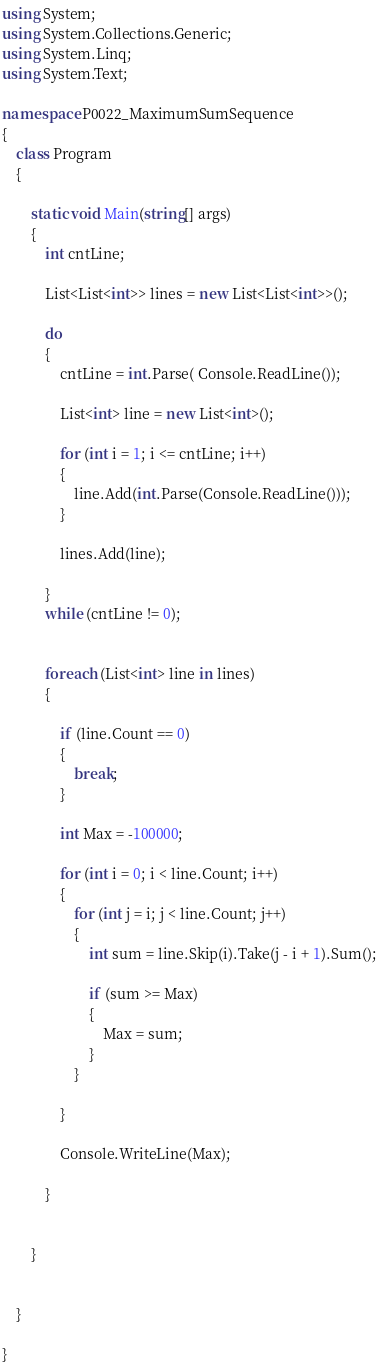Convert code to text. <code><loc_0><loc_0><loc_500><loc_500><_C#_>using System;
using System.Collections.Generic;
using System.Linq;
using System.Text;

namespace P0022_MaximumSumSequence
{
    class Program
    {

        static void Main(string[] args)
        {
            int cntLine;

            List<List<int>> lines = new List<List<int>>();

            do
            {
                cntLine = int.Parse( Console.ReadLine());
                
                List<int> line = new List<int>();

                for (int i = 1; i <= cntLine; i++) 
                {
                    line.Add(int.Parse(Console.ReadLine()));
                }

                lines.Add(line);

            }
            while (cntLine != 0);
            

            foreach (List<int> line in lines)
            {

                if (line.Count == 0) 
                {
                    break;
                }

                int Max = -100000;

                for (int i = 0; i < line.Count; i++) 
                {
                    for (int j = i; j < line.Count; j++)
                    {
                        int sum = line.Skip(i).Take(j - i + 1).Sum();

                        if (sum >= Max) 
                        {
                            Max = sum;
                        }
                    }

                }

                Console.WriteLine(Max);

            }


        }


    }

}</code> 